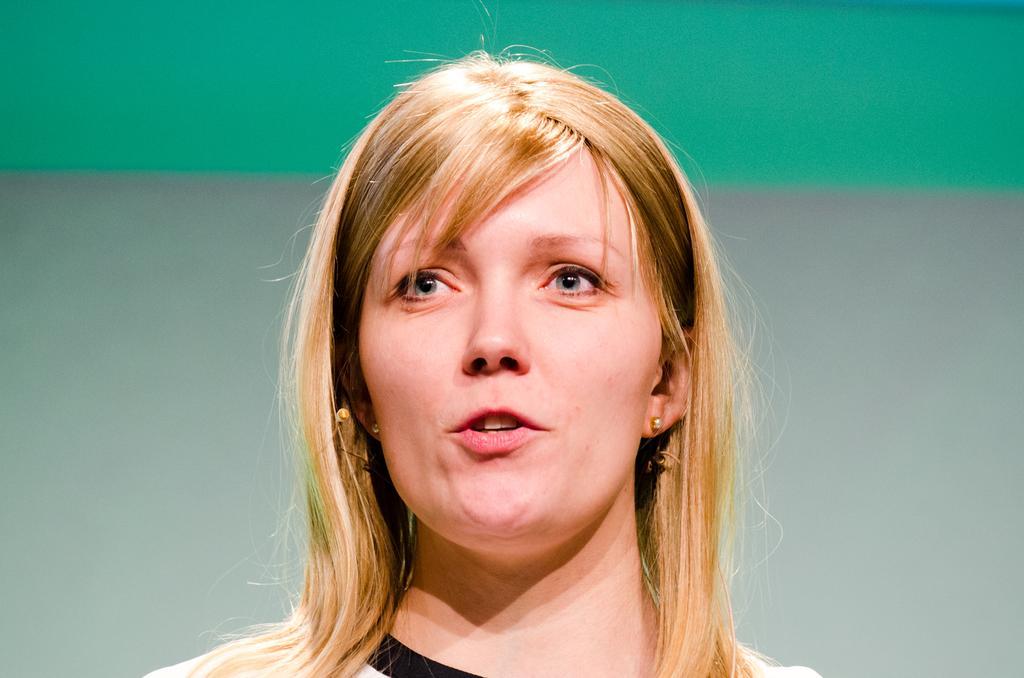How would you summarize this image in a sentence or two? In this image there is a woman, behind the woman there is a wall. 